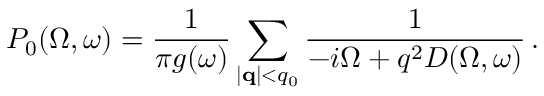Convert formula to latex. <formula><loc_0><loc_0><loc_500><loc_500>P _ { 0 } ( \Omega , \omega ) = \frac { 1 } { \pi g ( \omega ) } \sum _ { | { q } | < q _ { 0 } } \frac { 1 } { - i \Omega + q ^ { 2 } D ( \Omega , \omega ) } \, .</formula> 